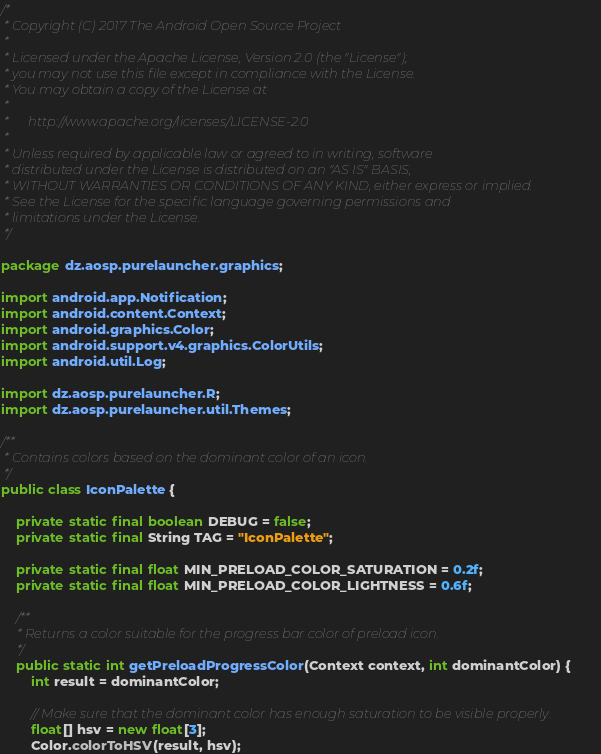<code> <loc_0><loc_0><loc_500><loc_500><_Java_>/*
 * Copyright (C) 2017 The Android Open Source Project
 *
 * Licensed under the Apache License, Version 2.0 (the "License");
 * you may not use this file except in compliance with the License.
 * You may obtain a copy of the License at
 *
 *      http://www.apache.org/licenses/LICENSE-2.0
 *
 * Unless required by applicable law or agreed to in writing, software
 * distributed under the License is distributed on an "AS IS" BASIS,
 * WITHOUT WARRANTIES OR CONDITIONS OF ANY KIND, either express or implied.
 * See the License for the specific language governing permissions and
 * limitations under the License.
 */

package dz.aosp.purelauncher.graphics;

import android.app.Notification;
import android.content.Context;
import android.graphics.Color;
import android.support.v4.graphics.ColorUtils;
import android.util.Log;

import dz.aosp.purelauncher.R;
import dz.aosp.purelauncher.util.Themes;

/**
 * Contains colors based on the dominant color of an icon.
 */
public class IconPalette {

    private static final boolean DEBUG = false;
    private static final String TAG = "IconPalette";

    private static final float MIN_PRELOAD_COLOR_SATURATION = 0.2f;
    private static final float MIN_PRELOAD_COLOR_LIGHTNESS = 0.6f;

    /**
     * Returns a color suitable for the progress bar color of preload icon.
     */
    public static int getPreloadProgressColor(Context context, int dominantColor) {
        int result = dominantColor;

        // Make sure that the dominant color has enough saturation to be visible properly.
        float[] hsv = new float[3];
        Color.colorToHSV(result, hsv);</code> 